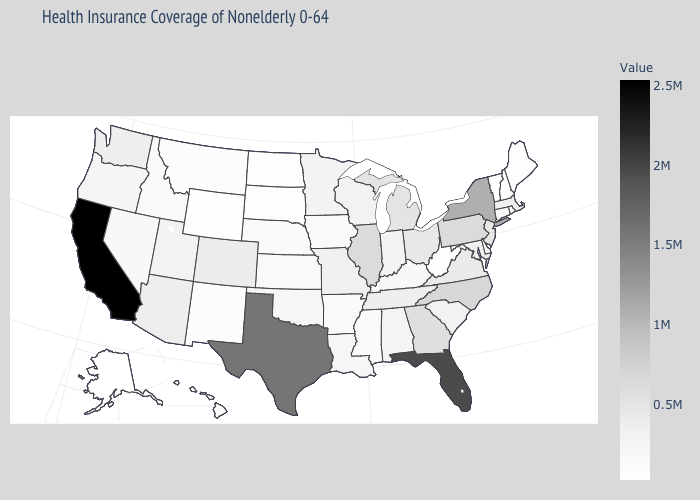Among the states that border Maryland , which have the lowest value?
Write a very short answer. Delaware. Among the states that border Georgia , which have the highest value?
Concise answer only. Florida. Which states hav the highest value in the South?
Write a very short answer. Florida. Which states have the lowest value in the USA?
Quick response, please. Alaska. Which states have the lowest value in the South?
Be succinct. Delaware. Does Alaska have the lowest value in the USA?
Concise answer only. Yes. Does Delaware have the lowest value in the South?
Give a very brief answer. Yes. 